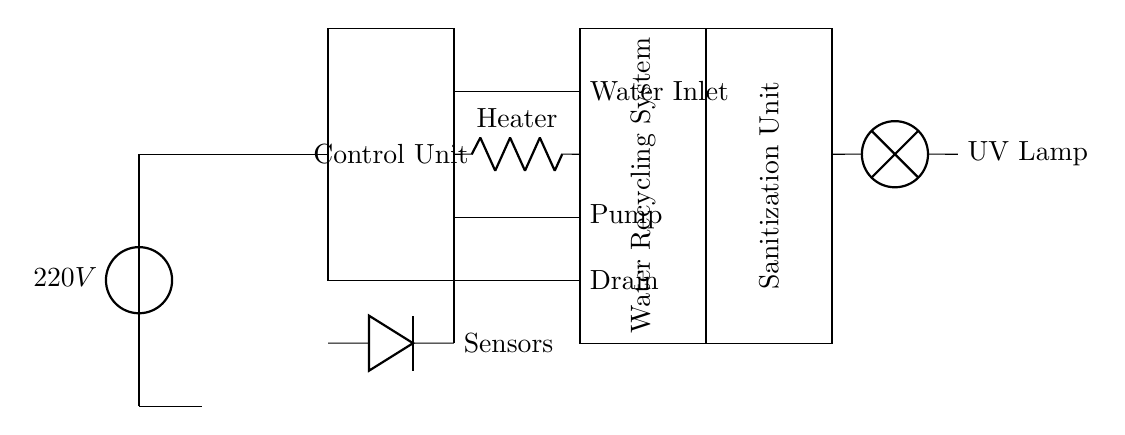What is the voltage of this circuit? The voltage is 220V, indicated at the power supply source at the beginning of the circuit.
Answer: 220V What is the purpose of the UV lamp? The UV lamp is used as part of the sanitization unit to eliminate harmful microorganisms in the water after recycling.
Answer: Sanitization How many main components are visible in the circuit? There are six main components: Control Unit, Water Inlet, Heater, Pump, Drain, and Water Recycling System.
Answer: Six What type of valve is used for draining water? The valve used for draining is labeled as "Drain" and is an electromechanical valve, specifically indicated in the diagram.
Answer: Drain What does the control unit do? The Control Unit manages the operation of other components such as the valves, pump, and heater based on input from sensors.
Answer: Manages operations Describe the connection between the heating element and the water inlet valve. The heating element is connected to the water inlet valve through a direct line, indicating that water flows from the inlet to be heated prior to use.
Answer: Direct connection What component is responsible for water recycling in the diagram? The Water Recycling System is responsible for processing used water to make it clean for reuse in the dishwasher cycle.
Answer: Water Recycling System 